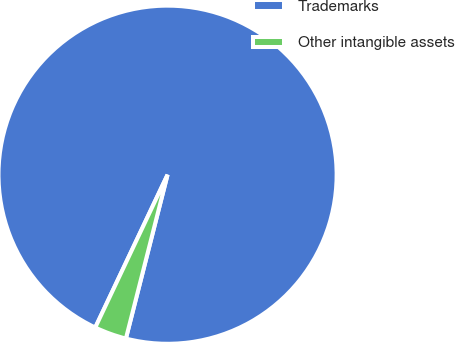<chart> <loc_0><loc_0><loc_500><loc_500><pie_chart><fcel>Trademarks<fcel>Other intangible assets<nl><fcel>96.93%<fcel>3.07%<nl></chart> 